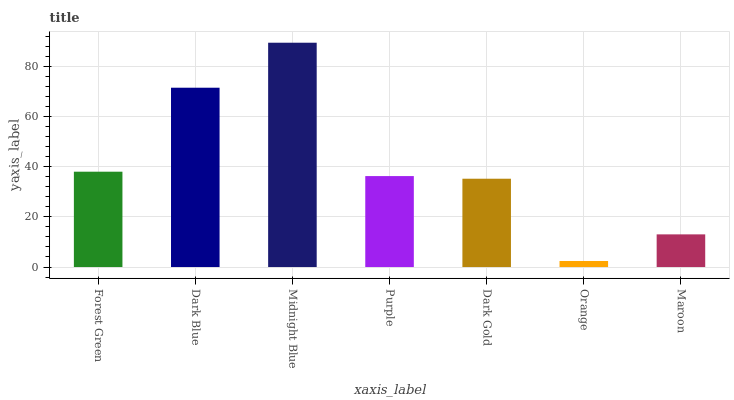Is Orange the minimum?
Answer yes or no. Yes. Is Midnight Blue the maximum?
Answer yes or no. Yes. Is Dark Blue the minimum?
Answer yes or no. No. Is Dark Blue the maximum?
Answer yes or no. No. Is Dark Blue greater than Forest Green?
Answer yes or no. Yes. Is Forest Green less than Dark Blue?
Answer yes or no. Yes. Is Forest Green greater than Dark Blue?
Answer yes or no. No. Is Dark Blue less than Forest Green?
Answer yes or no. No. Is Purple the high median?
Answer yes or no. Yes. Is Purple the low median?
Answer yes or no. Yes. Is Dark Gold the high median?
Answer yes or no. No. Is Forest Green the low median?
Answer yes or no. No. 